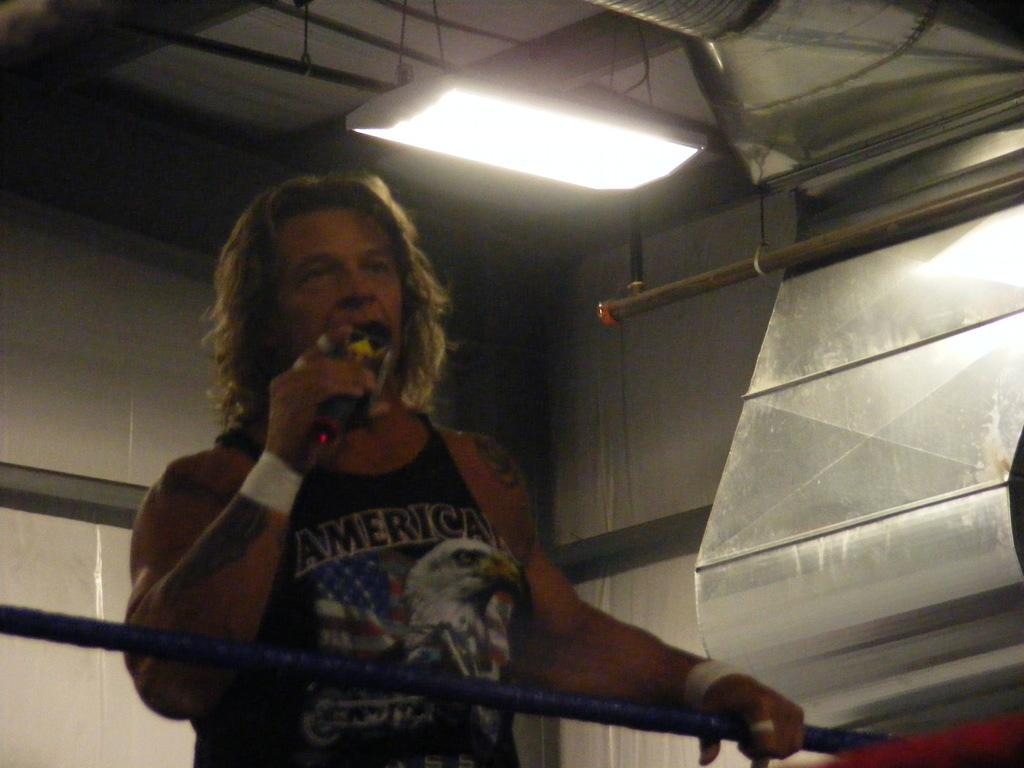What is the man in the image doing? The man is holding a microphone in his hand and talking. What object is the man holding in addition to the microphone? The man is holding a ring post. What can be seen in the background of the image? There is an air conditioner and a light attached to the roof in the background of the image. What type of machine is being taught by the man in the image? There is no machine present in the image, and the man is not teaching anything. Is the man in the image using ice to demonstrate a concept? There is no ice present in the image, and the man is not demonstrating any concept related to ice. 